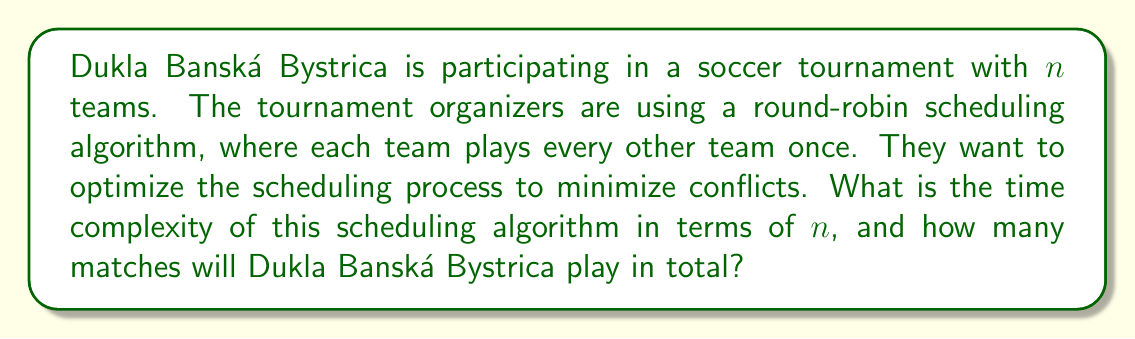Help me with this question. Let's break this down step-by-step:

1. In a round-robin tournament, each team plays every other team once. This means that for $n$ teams:

   - Each team plays $(n-1)$ matches
   - The total number of matches is $\frac{n(n-1)}{2}$

2. To generate this schedule, the algorithm needs to:
   a) Create a list of all possible team pairings
   b) Assign these pairings to time slots or rounds

3. Creating the list of all possible team pairings:
   - This requires comparing each team with every other team
   - This operation has a time complexity of $O(n^2)$

4. Assigning the pairings to time slots:
   - In the worst case, this could require checking each pairing against each time slot
   - With $\frac{n(n-1)}{2}$ matches and potentially up to $n-1$ rounds, this operation has a time complexity of $O(n^3)$

5. Therefore, the overall time complexity of the scheduling algorithm is $O(n^3)$

6. For Dukla Banská Bystrica specifically:
   - They will play against every other team once
   - So, they will play $(n-1)$ matches in total
Answer: The time complexity of the round-robin scheduling algorithm is $O(n^3)$, where $n$ is the number of teams. Dukla Banská Bystrica will play $(n-1)$ matches in total. 